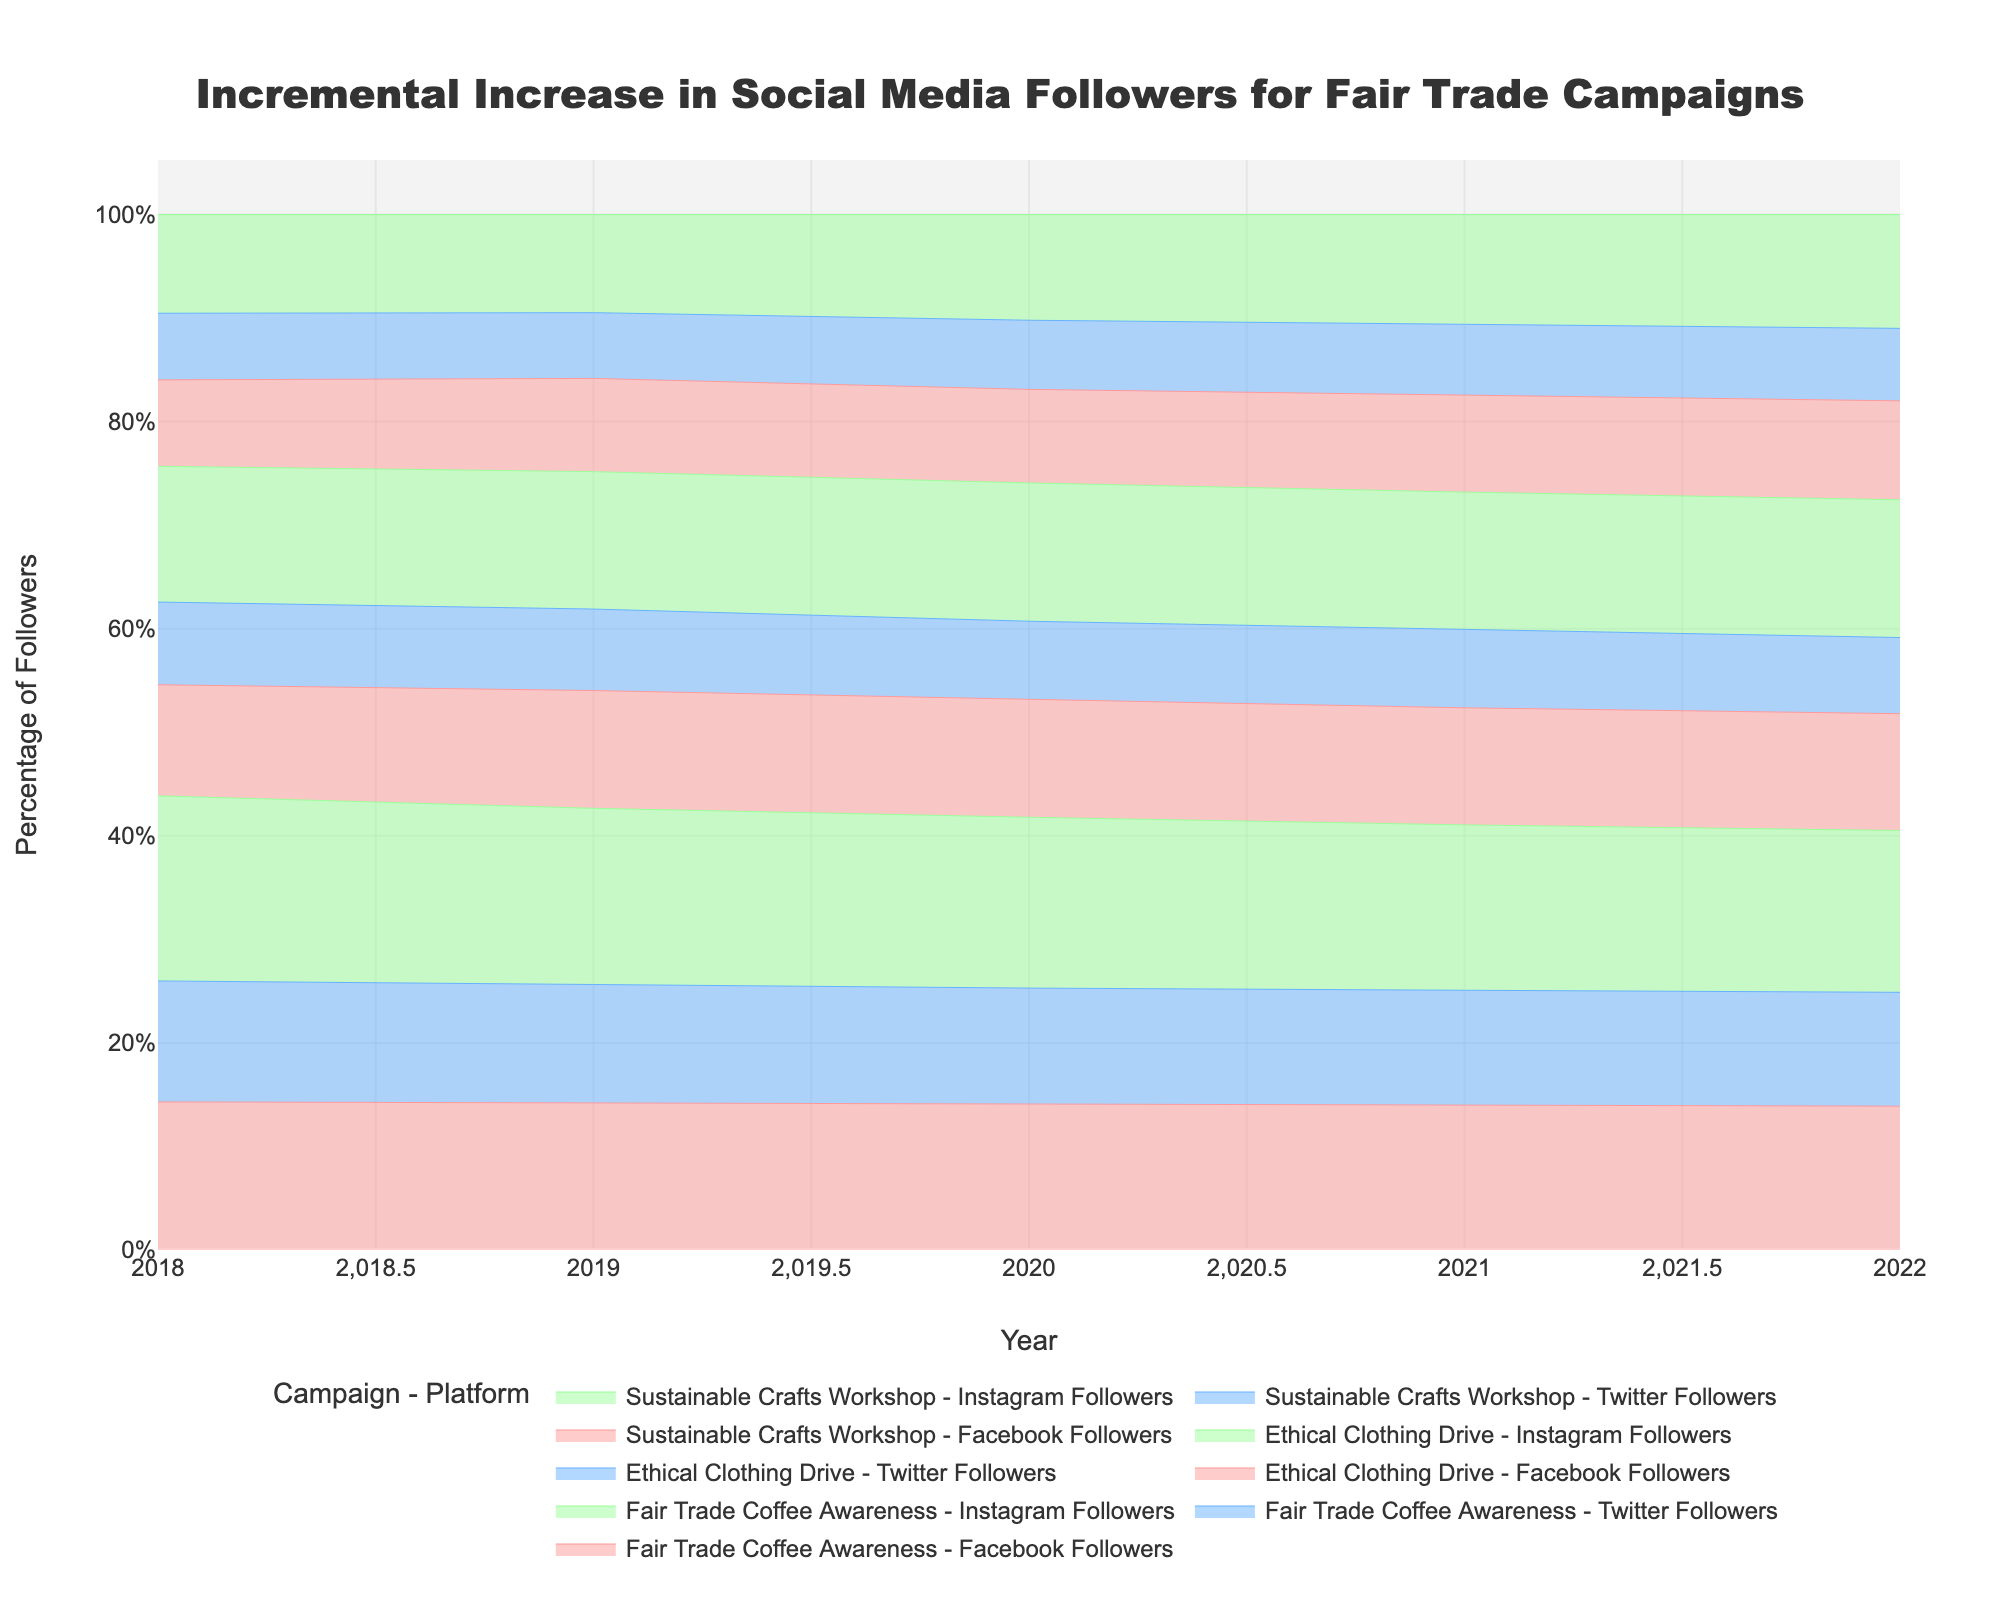what's the title of the chart? The title of the chart is usually located at the top center of the figure.
Answer: Incremental Increase in Social Media Followers for Fair Trade Campaigns What are the platforms displayed in the step area chart? By looking at the legend or the labels in the plot, you can see the platforms listed.
Answer: Facebook Followers, Twitter Followers, Instagram Followers How many years are covered in the chart data? The x-axis shows the timeline of the data. By counting the distinct tick marks on the x-axis, you can determine the number of years.
Answer: 5 years (2018 to 2022) Which campaign had the highest percentage of followers on Instagram in 2019? By looking at the data points for each campaign in 2019 and comparing their height for Instagram Followers.
Answer: Fair Trade Coffee Awareness Which year showed the highest percentage increase in Twitter followers for the "Ethical Clothing Drive" campaign? You need to compare the increments between years specifically for the Twitter Followers of the "Ethical Clothing Drive" campaign.
Answer: 2020 What percentage of followers did "Sustainable Crafts Workshop" have on Facebook in 2020? By locating the trace of "Sustainable Crafts Workshop" Facebook Followers, find the value corresponding to the year 2020.
Answer: 1150 Compare the total followers for "Fair Trade Coffee Awareness" in 2021, across all platforms. Sum the followers from Facebook, Twitter, and Instagram for the 2021 data of "Fair Trade Coffee Awareness".
Answer: 6170 How did the percentage of Twitter followers for the "Fair Trade Coffee Awareness" campaign change from 2019 to 2022? Evaluate the Twitter follower data for the "Fair Trade Coffee Awareness" campaign in both years and compute the difference or trend over these years.
Answer: Increased Which campaign had the smallest number of Twitter followers in 2018 and what was the number? By comparing the Twitter follower counts of all campaigns for the year 2018, identify the smallest count.
Answer: Sustainable Crafts Workshop, 540 How many platforms are represented by the color green in the chart? Examine the chart legend or the color assignments for each platform to determine how many uses green.
Answer: 1 (Instagram Followers) 